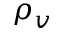Convert formula to latex. <formula><loc_0><loc_0><loc_500><loc_500>\rho _ { v }</formula> 